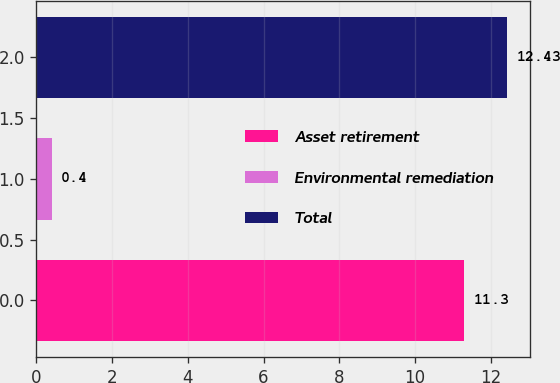Convert chart to OTSL. <chart><loc_0><loc_0><loc_500><loc_500><bar_chart><fcel>Asset retirement<fcel>Environmental remediation<fcel>Total<nl><fcel>11.3<fcel>0.4<fcel>12.43<nl></chart> 